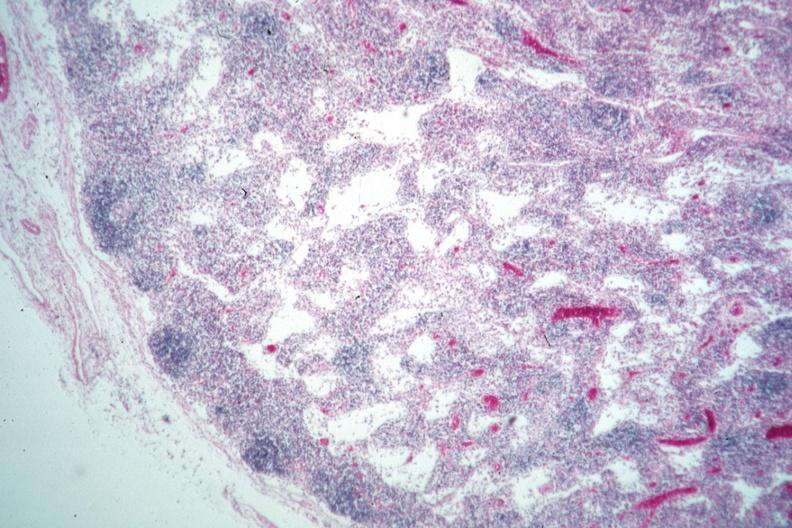does this image show nice example lymphocyte depleted medullary area?
Answer the question using a single word or phrase. Yes 